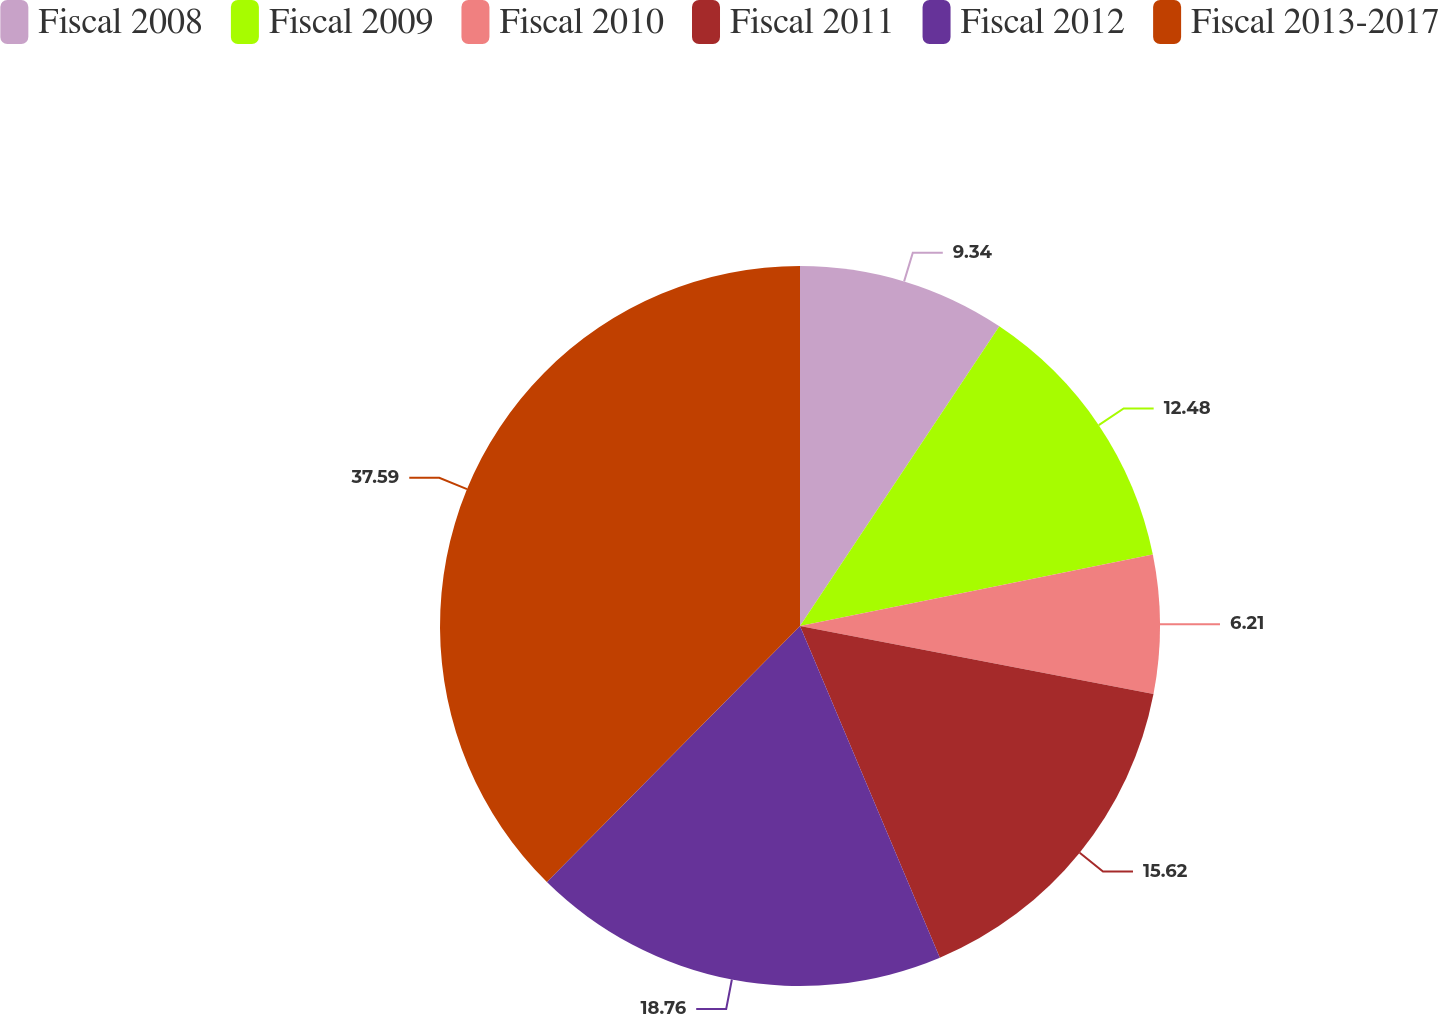Convert chart. <chart><loc_0><loc_0><loc_500><loc_500><pie_chart><fcel>Fiscal 2008<fcel>Fiscal 2009<fcel>Fiscal 2010<fcel>Fiscal 2011<fcel>Fiscal 2012<fcel>Fiscal 2013-2017<nl><fcel>9.34%<fcel>12.48%<fcel>6.21%<fcel>15.62%<fcel>18.76%<fcel>37.59%<nl></chart> 